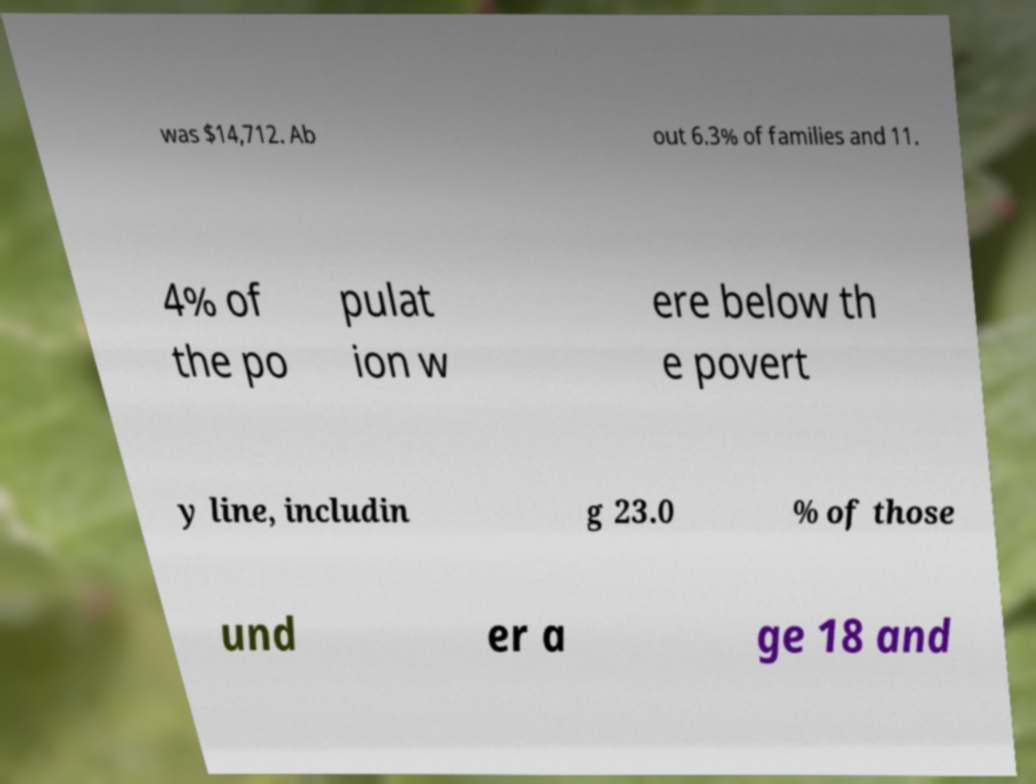Please read and relay the text visible in this image. What does it say? was $14,712. Ab out 6.3% of families and 11. 4% of the po pulat ion w ere below th e povert y line, includin g 23.0 % of those und er a ge 18 and 